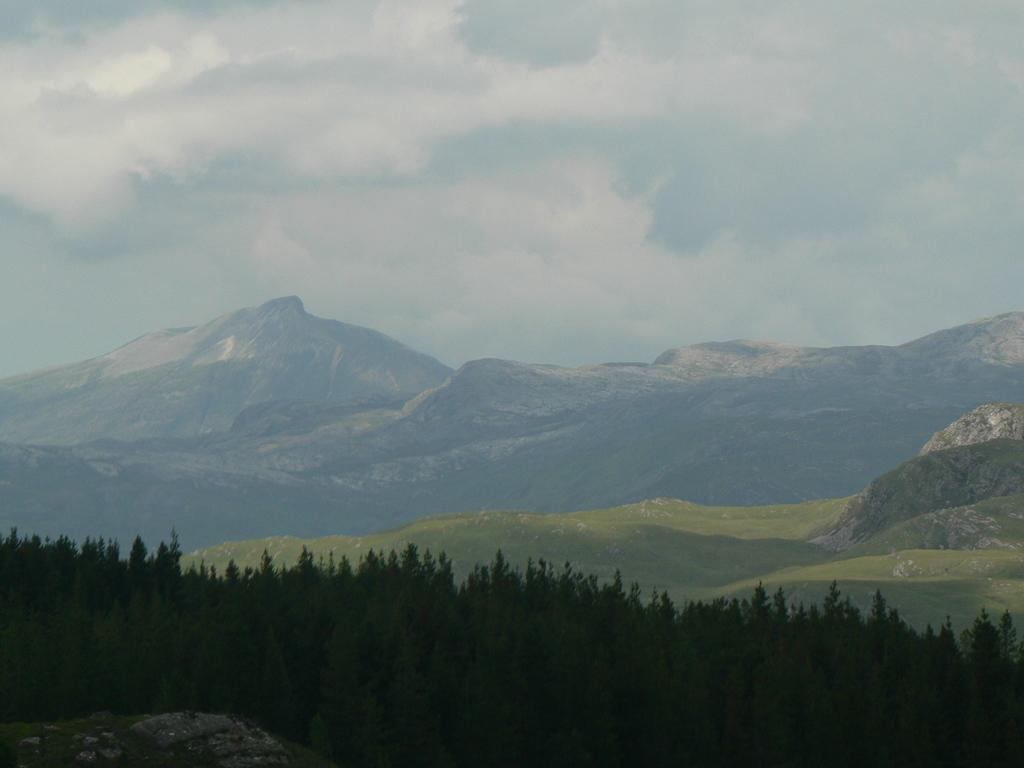Where was the image taken? The image was clicked outside. What can be seen in the foreground of the image? There are many plants and trees in the front of the image. What is visible in the background of the image? There are mountains in the background of the image. What is visible in the sky at the top of the image? There are clouds in the sky at the top of the image. What type of guitar is leaning against the tree in the image? There is no guitar present in the image; it features plants, trees, mountains, and clouds. 